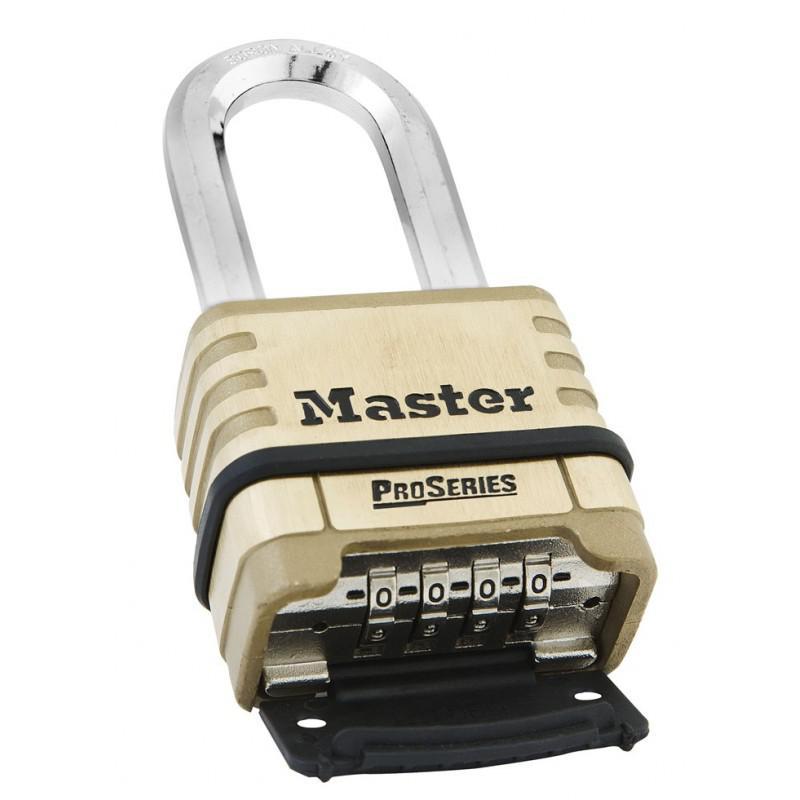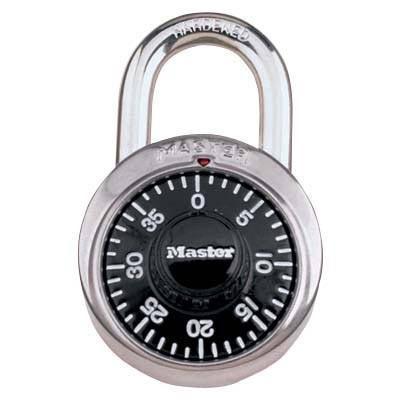The first image is the image on the left, the second image is the image on the right. Assess this claim about the two images: "The lock in the left image has combination numbers on the bottom of the lock.". Correct or not? Answer yes or no. Yes. The first image is the image on the left, the second image is the image on the right. Assess this claim about the two images: "There are two locks total and they are both the same color.". Correct or not? Answer yes or no. No. 